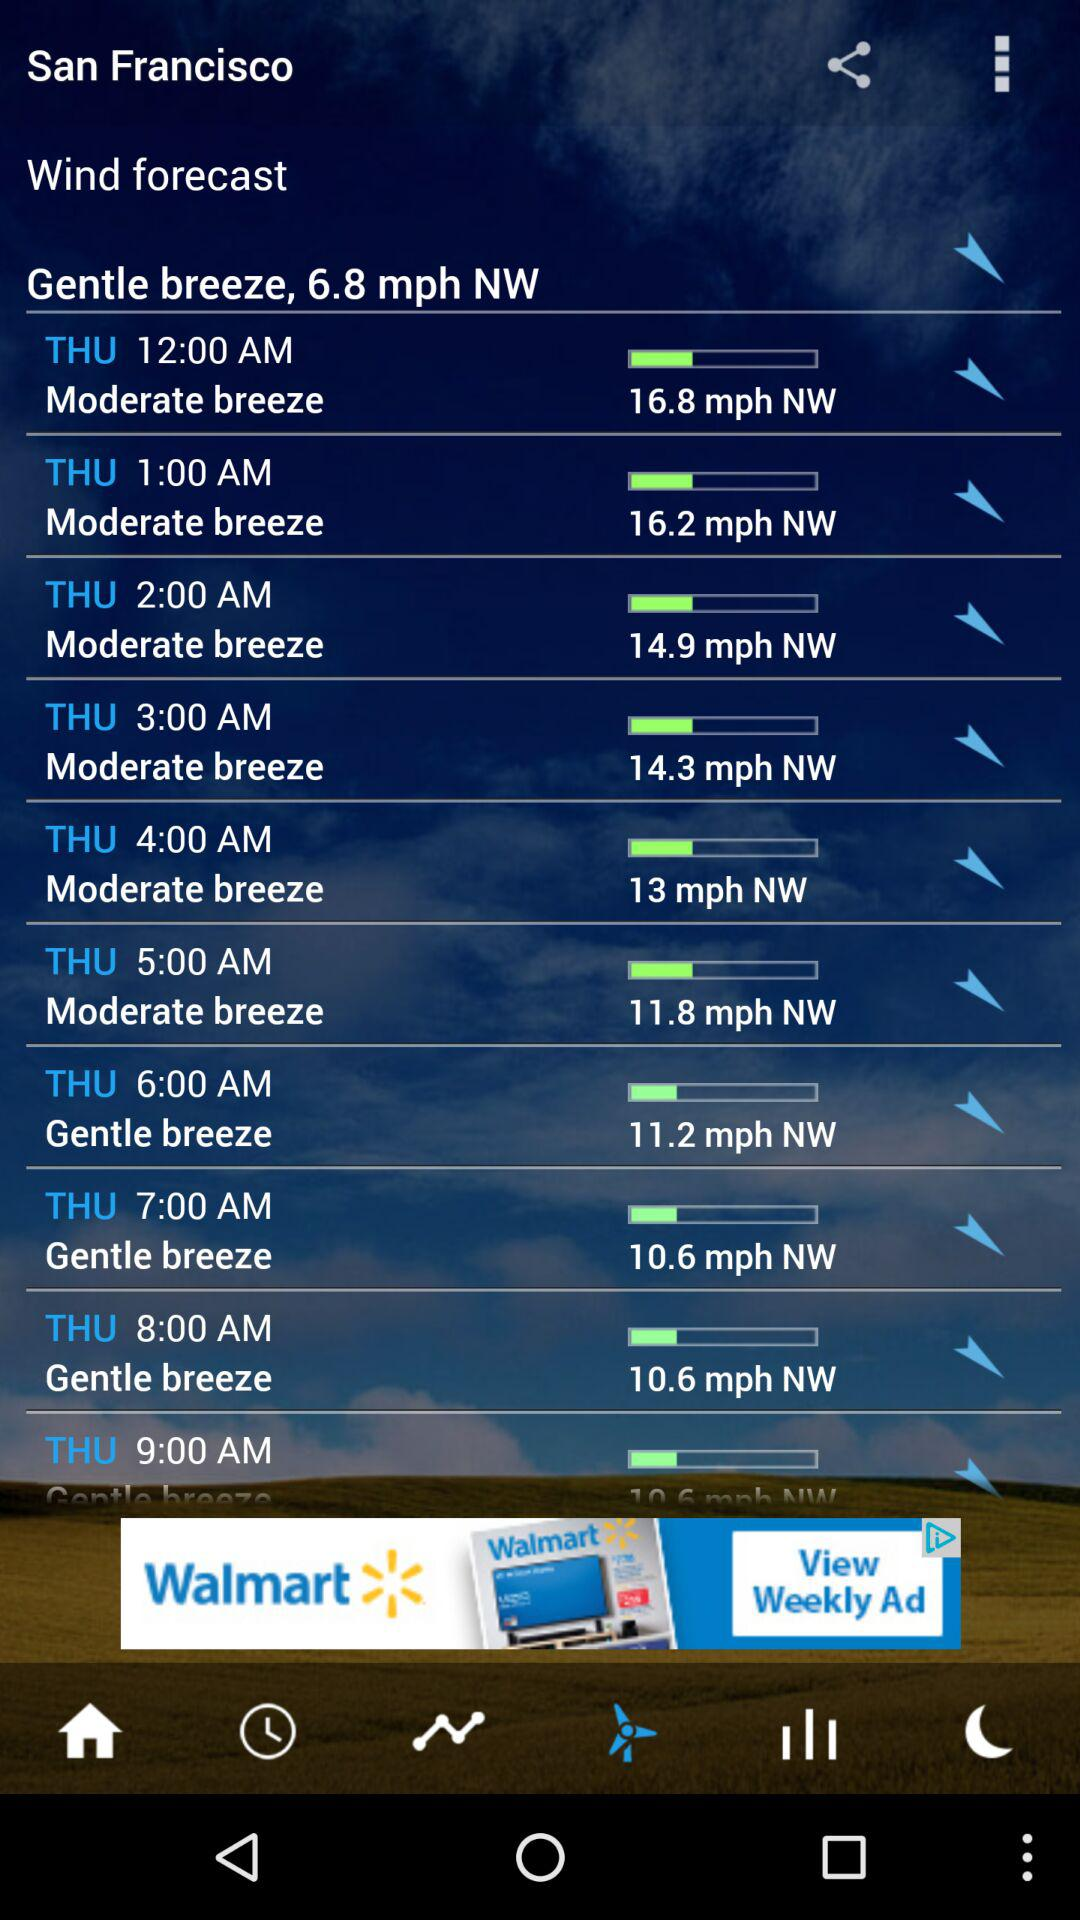What is the wind speed on Thursday at 2:00 a.m.? The wind speed on Thursday at 2:00 a.m. is 14.9 miles per hour. 